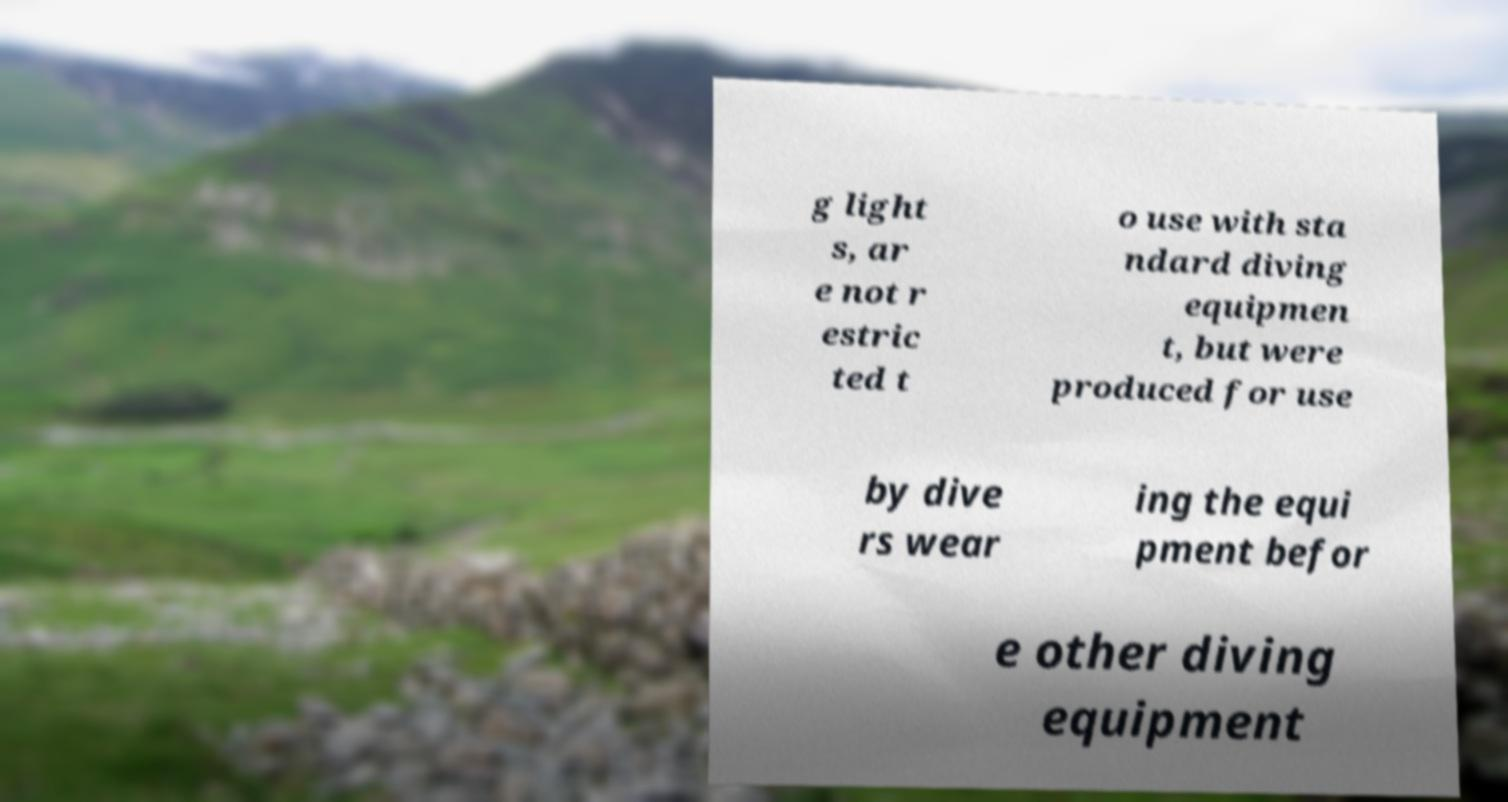What messages or text are displayed in this image? I need them in a readable, typed format. g light s, ar e not r estric ted t o use with sta ndard diving equipmen t, but were produced for use by dive rs wear ing the equi pment befor e other diving equipment 